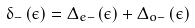Convert formula to latex. <formula><loc_0><loc_0><loc_500><loc_500>\delta _ { - } \left ( \epsilon \right ) = \Delta _ { e - } \left ( \epsilon \right ) + \Delta _ { o - } \left ( \epsilon \right )</formula> 